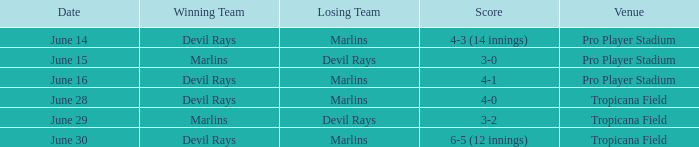What was the score on june 29? 3-2. 